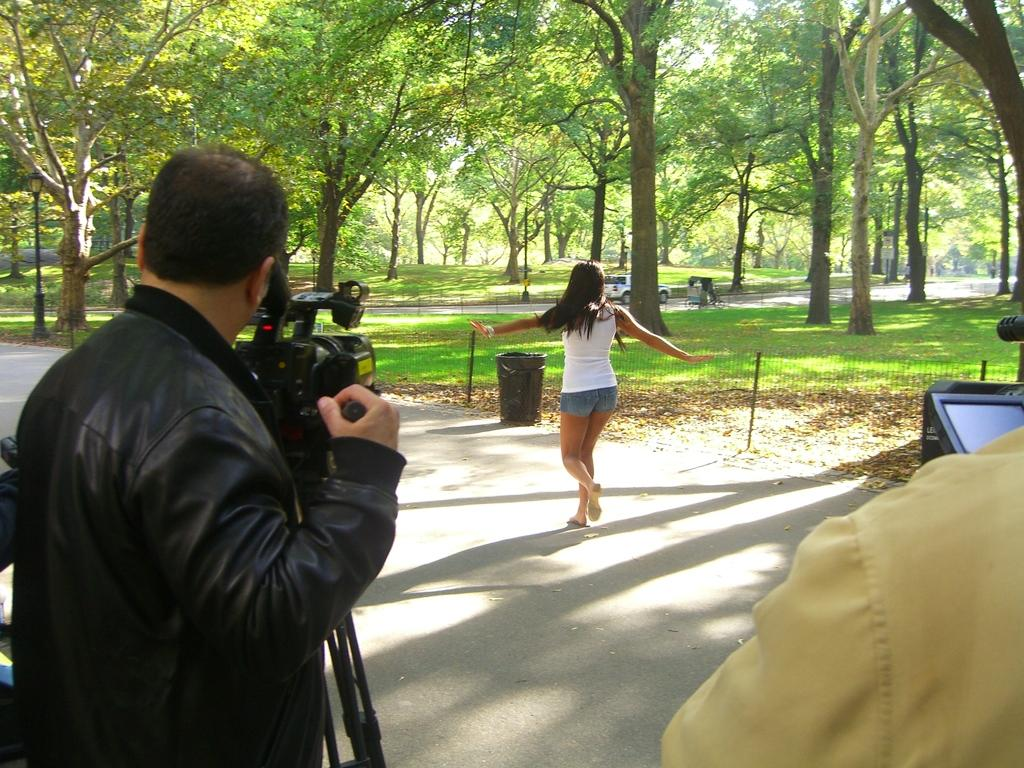What is the man wearing in the image? The man is wearing a black jacket. What is the man holding in the image? The man is holding a camera. What is the woman doing in the image? The woman is walking, as indicated by leg movement. What type of vegetation is visible in the image? There are trees visible in the image. What can be seen on the road in the image? There are vehicles on the road. What object is present for waste disposal in the image? There is a bin in the image. What type of ground cover is present in the image? Grass is present in the image. What type of cloud is responsible for the man's feeling of shame in the image? There is no mention of shame or clouds in the image, so it is not possible to answer that question. 